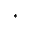Convert formula to latex. <formula><loc_0><loc_0><loc_500><loc_500>^ { * }</formula> 